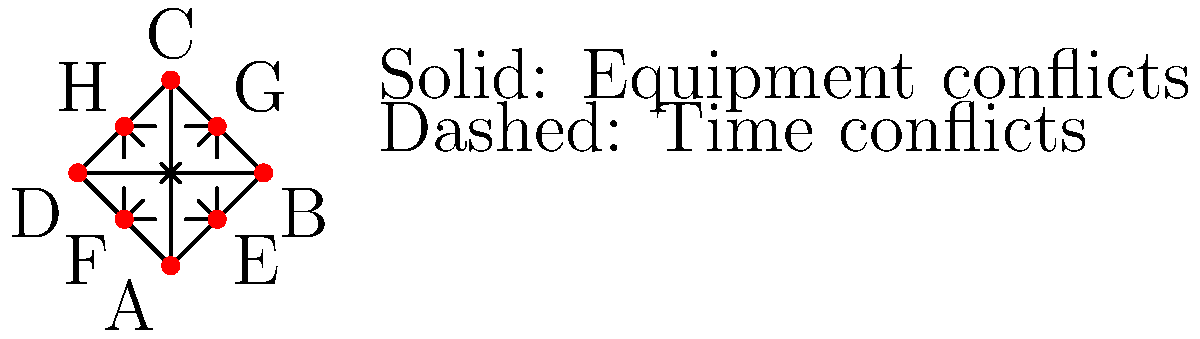In a cutting-edge research laboratory, you're tasked with optimizing the schedule for various experiments. The graph represents equipment and time conflicts between experiments (A-H). Solid lines indicate equipment conflicts, while dashed lines represent time conflicts. What is the minimum number of time slots needed to schedule all experiments without conflicts, assuming experiments with the same color can be conducted simultaneously? To solve this graph coloring problem, we'll follow these steps:

1) Identify the maximum clique in the graph:
   - The solid lines form a clique of size 4 (A, B, C, D).
   - The dashed lines form a clique of size 4 (E, F, G, H).
   - There are no larger cliques.

2) The chromatic number of a graph is at least as large as its maximum clique size. So, we need at least 4 colors.

3) Let's attempt to color the graph with 4 colors:
   - Assign color 1 to A, color 2 to B, color 3 to C, and color 4 to D.
   - For E, we can use color 1 as it doesn't conflict with A.
   - For F, we can use color 2.
   - For G, we can use color 3.
   - For H, we can use color 4.

4) This coloring satisfies all constraints:
   - No two adjacent vertices (connected by either solid or dashed lines) have the same color.
   - We used exactly 4 colors.

5) Therefore, 4 is both the lower bound and achievable, so it's the minimum number of colors needed.

In the context of scheduling, each color represents a time slot. Thus, we need a minimum of 4 time slots to schedule all experiments without conflicts.
Answer: 4 time slots 